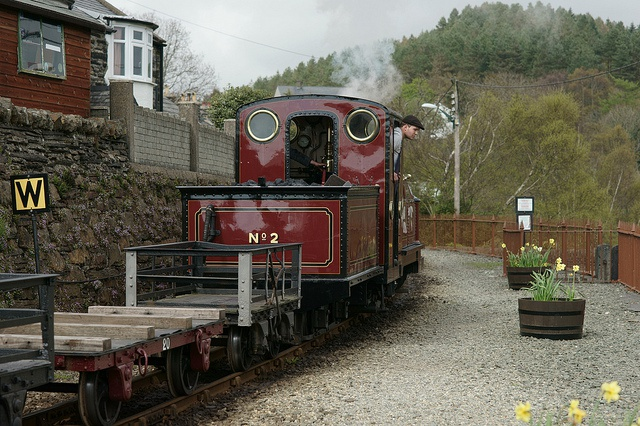Describe the objects in this image and their specific colors. I can see train in black, maroon, and gray tones, potted plant in black, gray, and darkgreen tones, potted plant in black, darkgray, and khaki tones, potted plant in black, darkgreen, and olive tones, and people in black, darkgray, and gray tones in this image. 